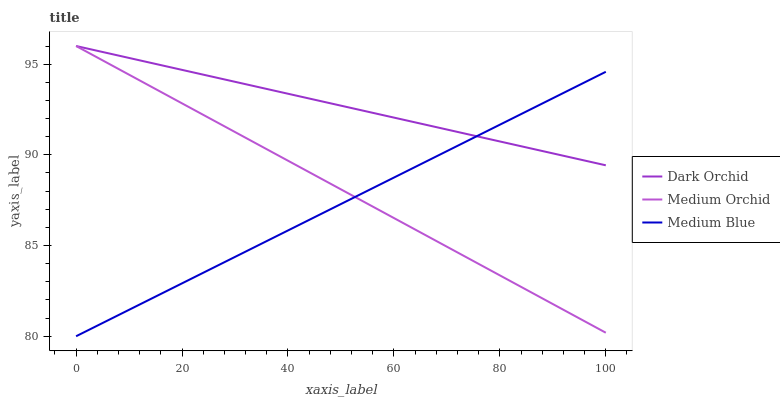Does Medium Blue have the minimum area under the curve?
Answer yes or no. Yes. Does Dark Orchid have the maximum area under the curve?
Answer yes or no. Yes. Does Dark Orchid have the minimum area under the curve?
Answer yes or no. No. Does Medium Blue have the maximum area under the curve?
Answer yes or no. No. Is Medium Orchid the smoothest?
Answer yes or no. Yes. Is Medium Blue the roughest?
Answer yes or no. Yes. Is Dark Orchid the smoothest?
Answer yes or no. No. Is Dark Orchid the roughest?
Answer yes or no. No. Does Dark Orchid have the lowest value?
Answer yes or no. No. Does Medium Blue have the highest value?
Answer yes or no. No. 